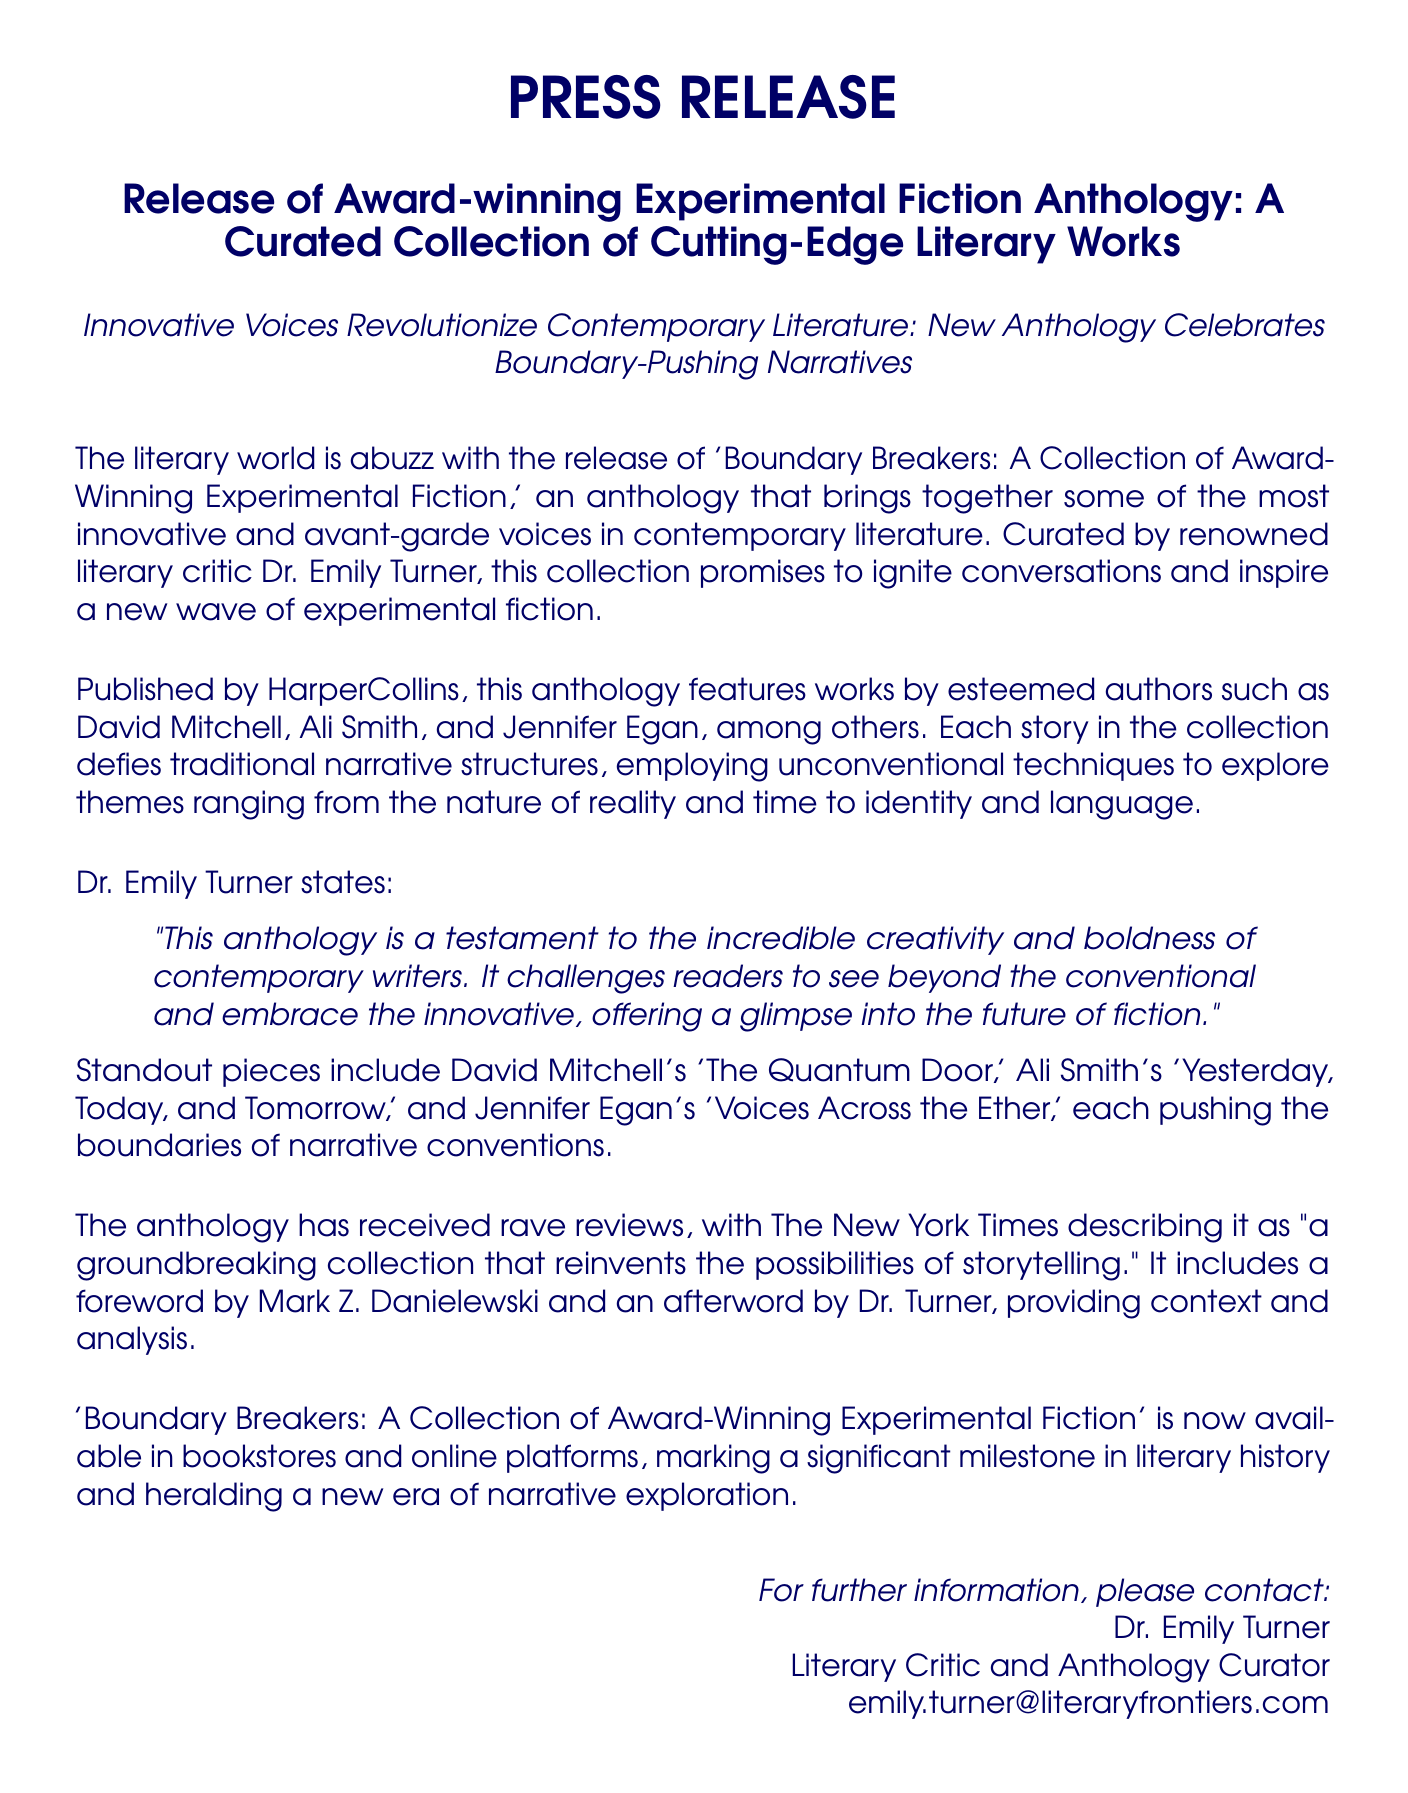What is the title of the anthology? The title of the anthology is explicitly mentioned in the document, "Boundary Breakers: A Collection of Award-Winning Experimental Fiction."
Answer: Boundary Breakers: A Collection of Award-Winning Experimental Fiction Who curated the anthology? The document specifies that the anthology was curated by Dr. Emily Turner.
Answer: Dr. Emily Turner Which publisher released the anthology? The document states that the anthology is published by HarperCollins.
Answer: HarperCollins Name one author featured in the anthology. The document provides names of several authors featured in the anthology, one of which is David Mitchell.
Answer: David Mitchell What is the genre of the works included in the anthology? The document describes the works as "experimental fiction," which indicates the genre.
Answer: Experimental fiction How has The New York Times described the anthology? The document quotes The New York Times describing the anthology as "a groundbreaking collection that reinvents the possibilities of storytelling."
Answer: A groundbreaking collection that reinvents the possibilities of storytelling What kind of techniques do the stories in the anthology employ? The document mentions that the stories employ "unconventional techniques" to explore various themes.
Answer: Unconventional techniques Does the anthology include any foreword? The document specifies that there is a foreword included, written by Mark Z. Danielewski.
Answer: Yes What significant milestone does the anthology mark? The document states that the anthology marks a significant milestone in literary history and heralds a new era of narrative exploration.
Answer: A significant milestone in literary history 